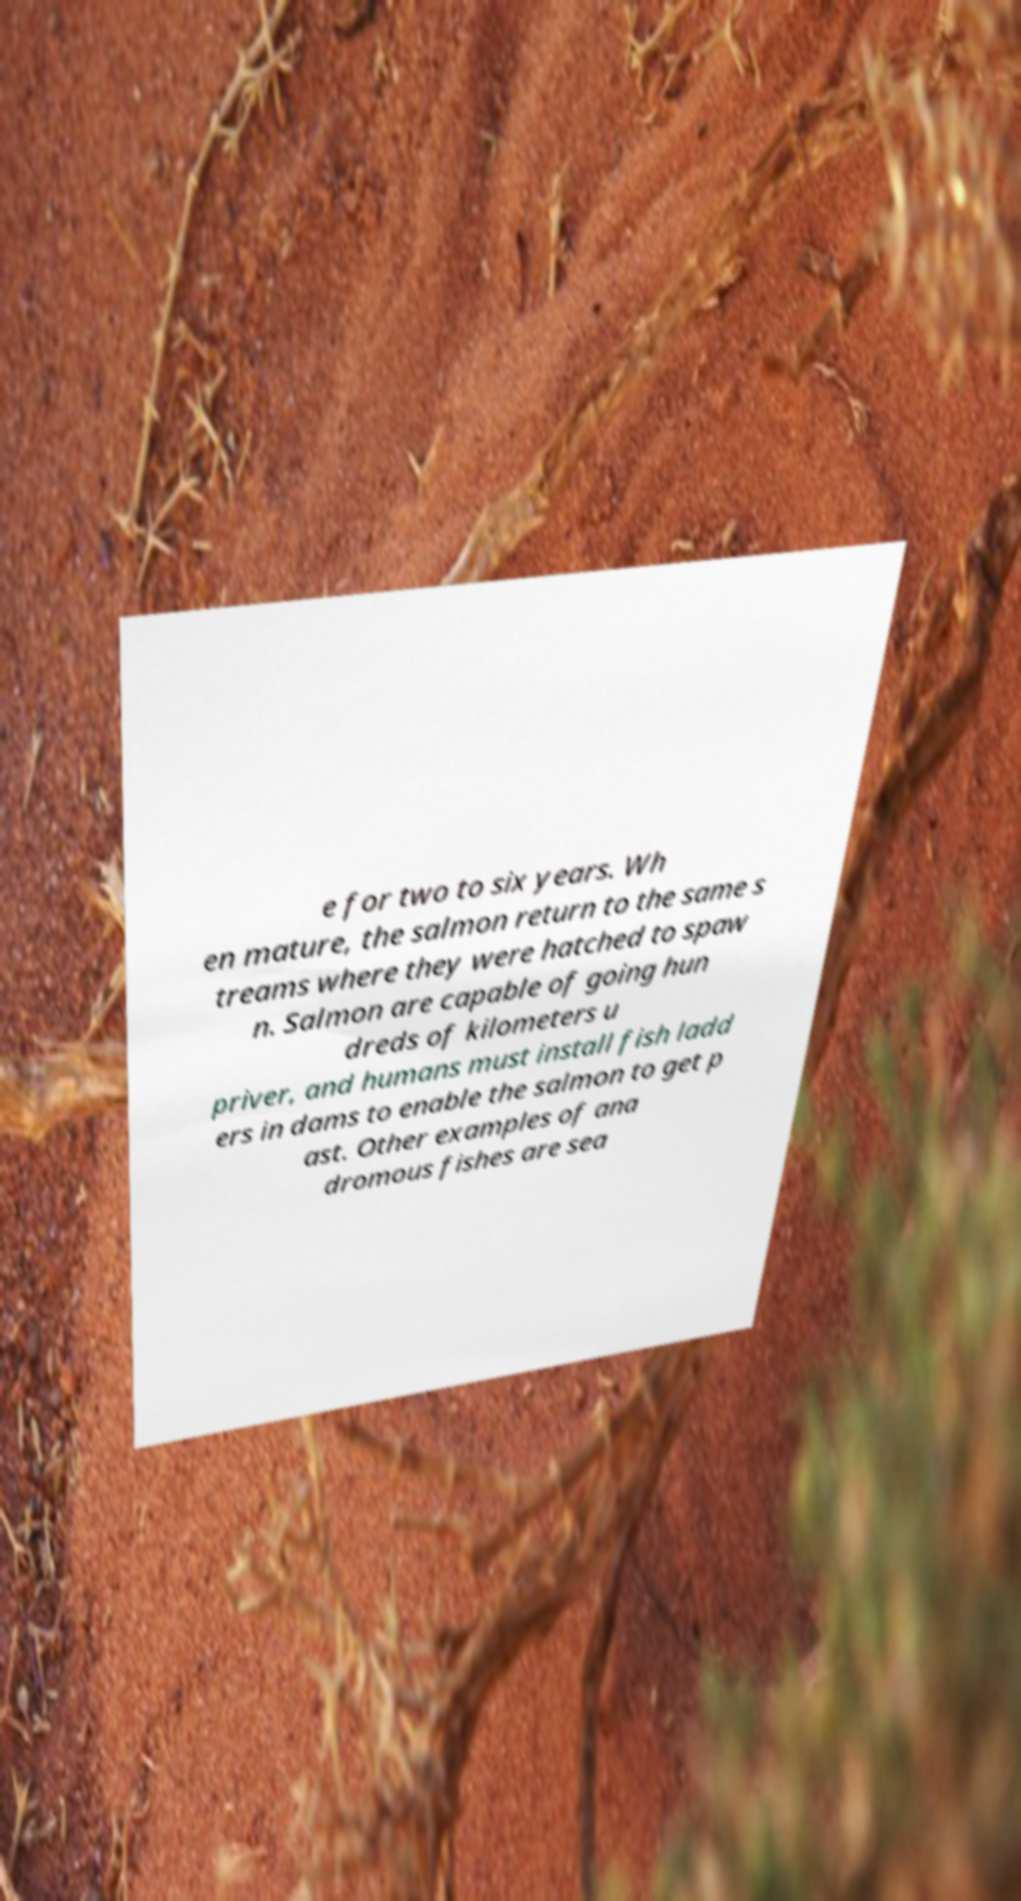Could you extract and type out the text from this image? e for two to six years. Wh en mature, the salmon return to the same s treams where they were hatched to spaw n. Salmon are capable of going hun dreds of kilometers u priver, and humans must install fish ladd ers in dams to enable the salmon to get p ast. Other examples of ana dromous fishes are sea 